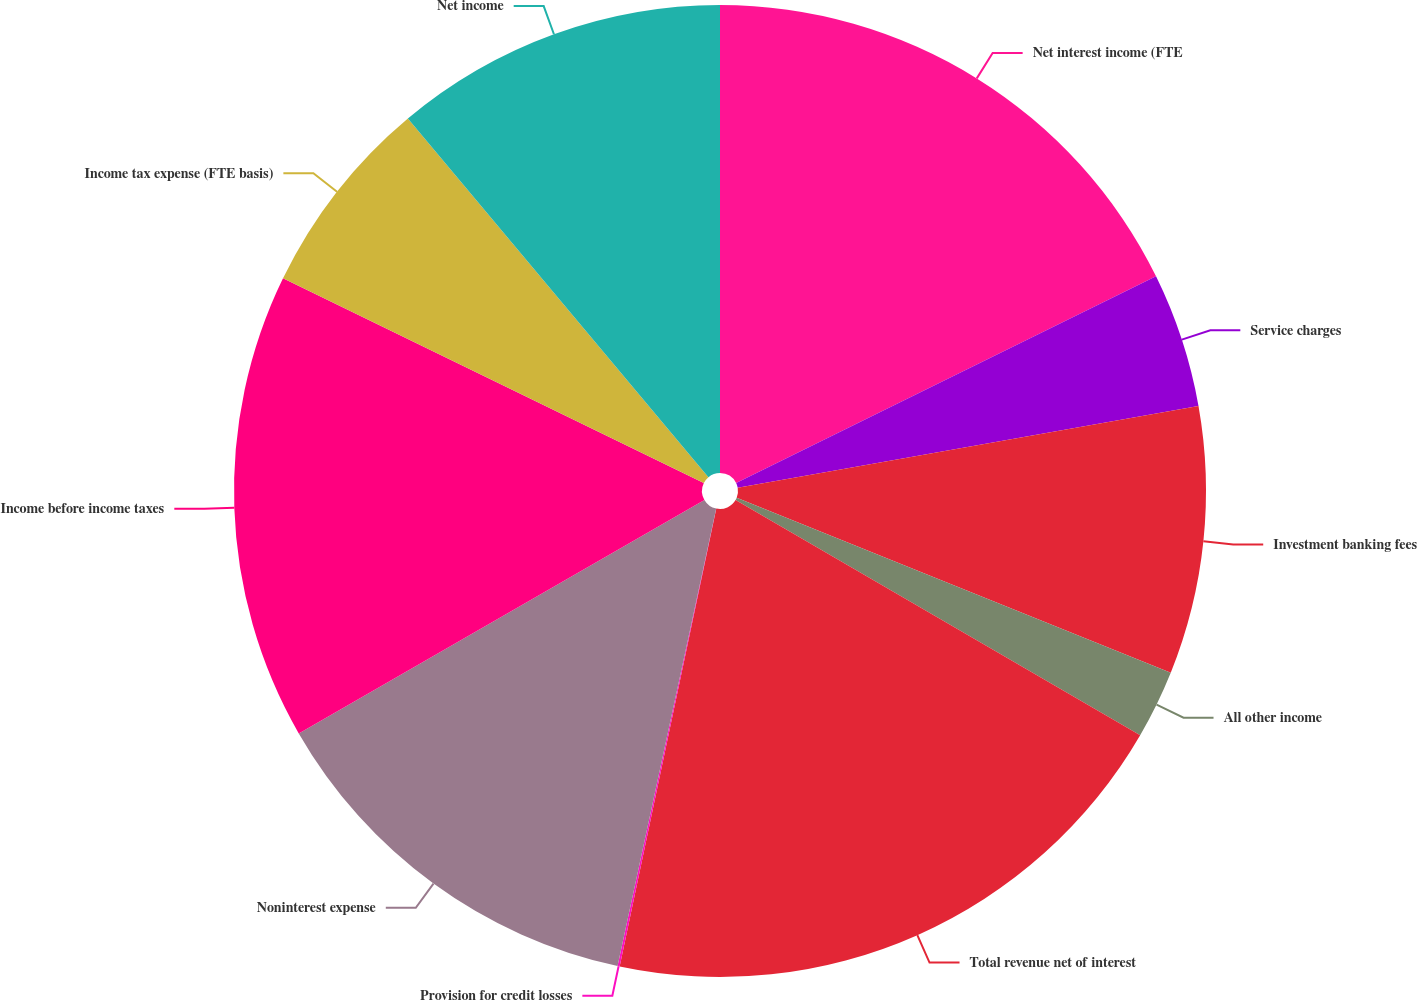Convert chart. <chart><loc_0><loc_0><loc_500><loc_500><pie_chart><fcel>Net interest income (FTE<fcel>Service charges<fcel>Investment banking fees<fcel>All other income<fcel>Total revenue net of interest<fcel>Provision for credit losses<fcel>Noninterest expense<fcel>Income before income taxes<fcel>Income tax expense (FTE basis)<fcel>Net income<nl><fcel>17.72%<fcel>4.48%<fcel>8.9%<fcel>2.28%<fcel>19.93%<fcel>0.07%<fcel>13.31%<fcel>15.52%<fcel>6.69%<fcel>11.1%<nl></chart> 